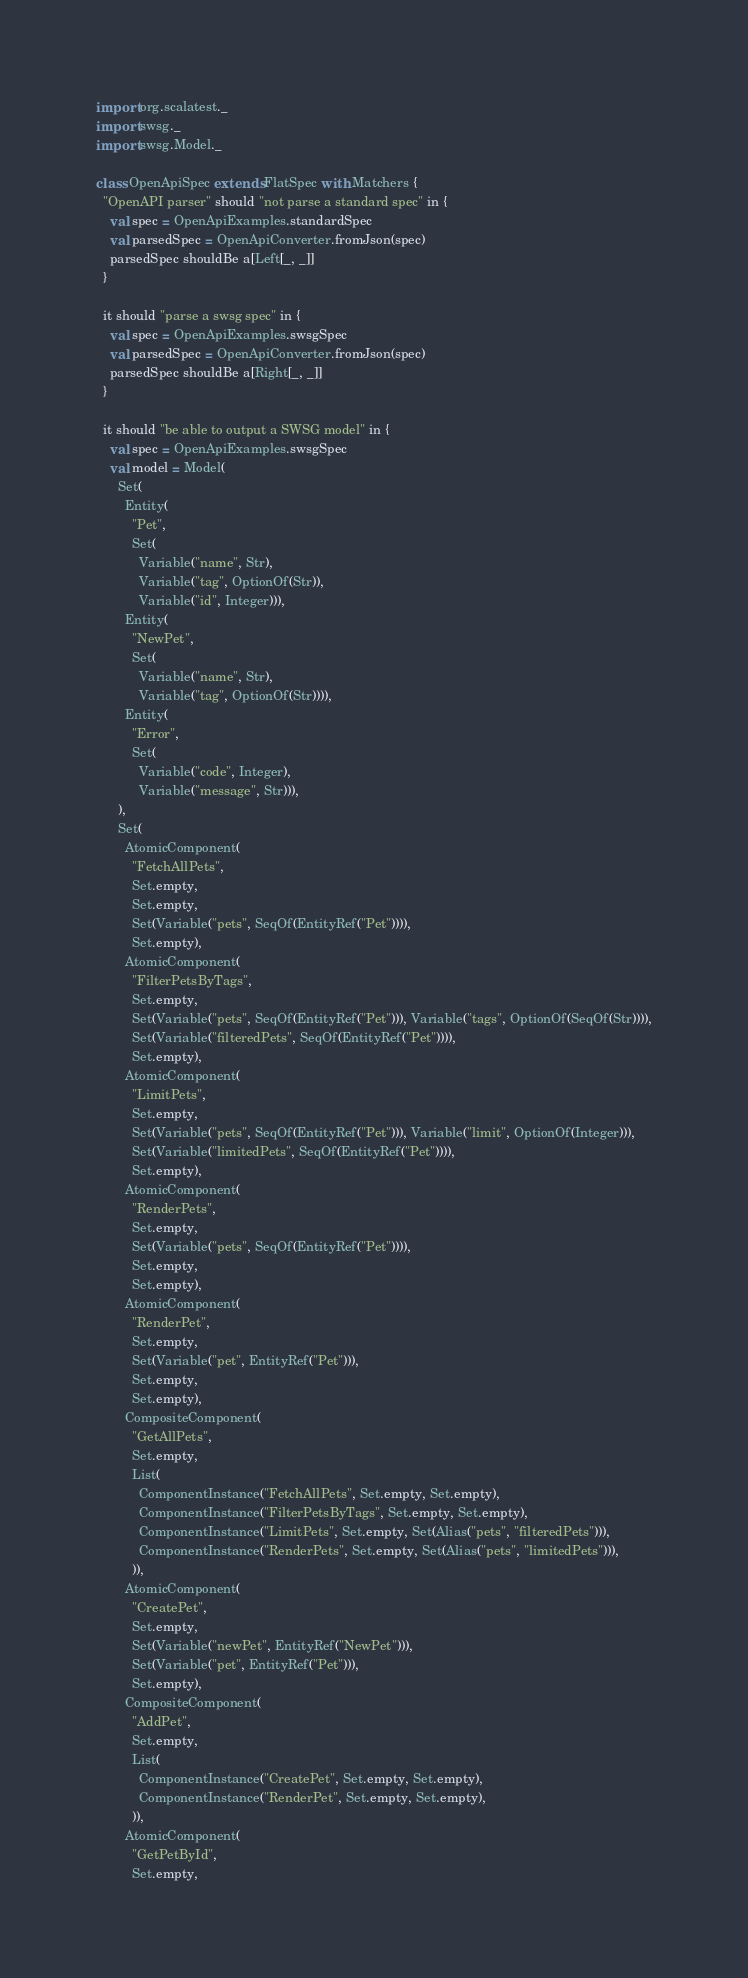<code> <loc_0><loc_0><loc_500><loc_500><_Scala_>import org.scalatest._
import swsg._
import swsg.Model._

class OpenApiSpec extends FlatSpec with Matchers {
  "OpenAPI parser" should "not parse a standard spec" in {
    val spec = OpenApiExamples.standardSpec
    val parsedSpec = OpenApiConverter.fromJson(spec)
    parsedSpec shouldBe a[Left[_, _]]
  }

  it should "parse a swsg spec" in {
    val spec = OpenApiExamples.swsgSpec
    val parsedSpec = OpenApiConverter.fromJson(spec)
    parsedSpec shouldBe a[Right[_, _]]
  }

  it should "be able to output a SWSG model" in {
    val spec = OpenApiExamples.swsgSpec
    val model = Model(
      Set(
        Entity(
          "Pet",
          Set(
            Variable("name", Str),
            Variable("tag", OptionOf(Str)),
            Variable("id", Integer))),
        Entity(
          "NewPet",
          Set(
            Variable("name", Str),
            Variable("tag", OptionOf(Str)))),
        Entity(
          "Error",
          Set(
            Variable("code", Integer),
            Variable("message", Str))),
      ),
      Set(
        AtomicComponent(
          "FetchAllPets",
          Set.empty,
          Set.empty,
          Set(Variable("pets", SeqOf(EntityRef("Pet")))),
          Set.empty),
        AtomicComponent(
          "FilterPetsByTags",
          Set.empty,
          Set(Variable("pets", SeqOf(EntityRef("Pet"))), Variable("tags", OptionOf(SeqOf(Str)))),
          Set(Variable("filteredPets", SeqOf(EntityRef("Pet")))),
          Set.empty),
        AtomicComponent(
          "LimitPets",
          Set.empty,
          Set(Variable("pets", SeqOf(EntityRef("Pet"))), Variable("limit", OptionOf(Integer))),
          Set(Variable("limitedPets", SeqOf(EntityRef("Pet")))),
          Set.empty),
        AtomicComponent(
          "RenderPets",
          Set.empty,
          Set(Variable("pets", SeqOf(EntityRef("Pet")))),
          Set.empty,
          Set.empty),
        AtomicComponent(
          "RenderPet",
          Set.empty,
          Set(Variable("pet", EntityRef("Pet"))),
          Set.empty,
          Set.empty),
        CompositeComponent(
          "GetAllPets",
          Set.empty,
          List(
            ComponentInstance("FetchAllPets", Set.empty, Set.empty),
            ComponentInstance("FilterPetsByTags", Set.empty, Set.empty),
            ComponentInstance("LimitPets", Set.empty, Set(Alias("pets", "filteredPets"))),
            ComponentInstance("RenderPets", Set.empty, Set(Alias("pets", "limitedPets"))),
          )),
        AtomicComponent(
          "CreatePet",
          Set.empty,
          Set(Variable("newPet", EntityRef("NewPet"))),
          Set(Variable("pet", EntityRef("Pet"))),
          Set.empty),
        CompositeComponent(
          "AddPet",
          Set.empty,
          List(
            ComponentInstance("CreatePet", Set.empty, Set.empty),
            ComponentInstance("RenderPet", Set.empty, Set.empty),
          )),
        AtomicComponent(
          "GetPetById",
          Set.empty,</code> 